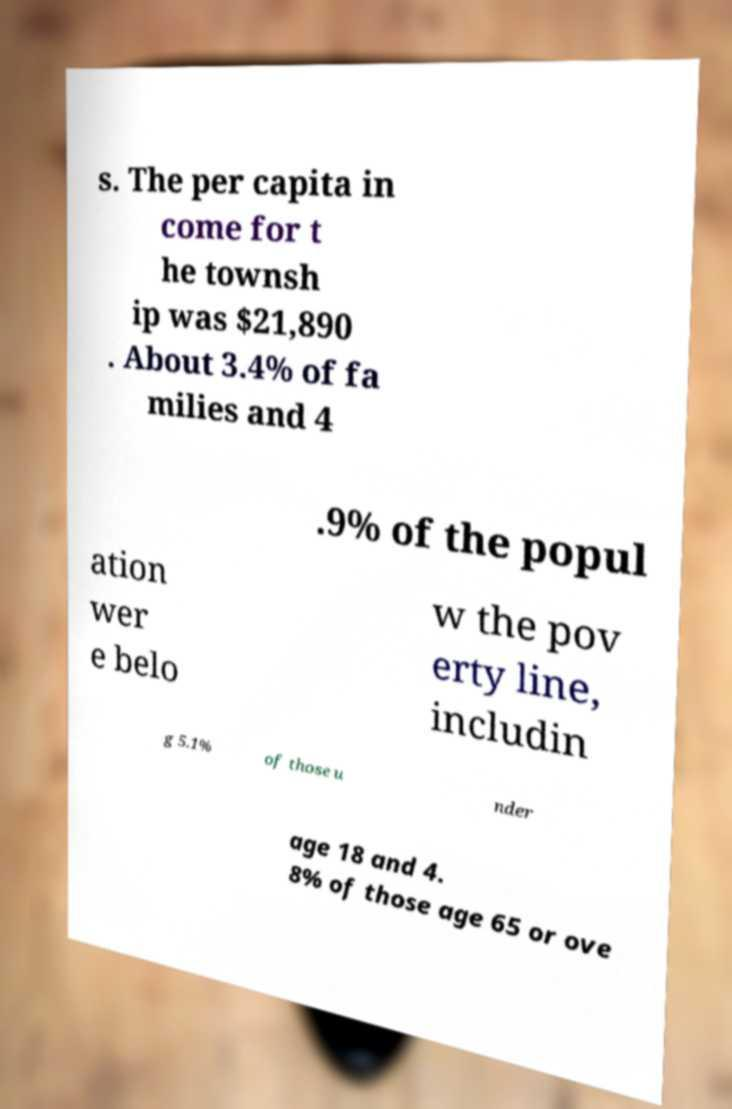I need the written content from this picture converted into text. Can you do that? s. The per capita in come for t he townsh ip was $21,890 . About 3.4% of fa milies and 4 .9% of the popul ation wer e belo w the pov erty line, includin g 5.1% of those u nder age 18 and 4. 8% of those age 65 or ove 